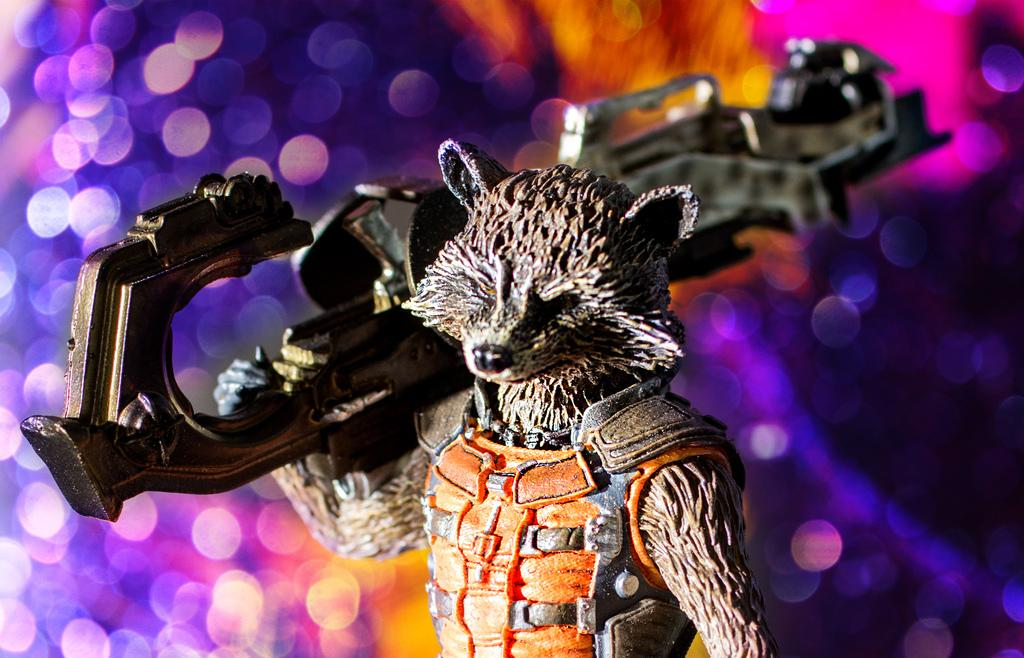What object can be seen in the image? There is a toy in the image. What can be seen in the background of the image? There are lights in the background of the image. How many birds are carrying the parcel in the image? There are no birds or parcels present in the image. What is the value of the toy in the image? The value of the toy cannot be determined from the image alone. 